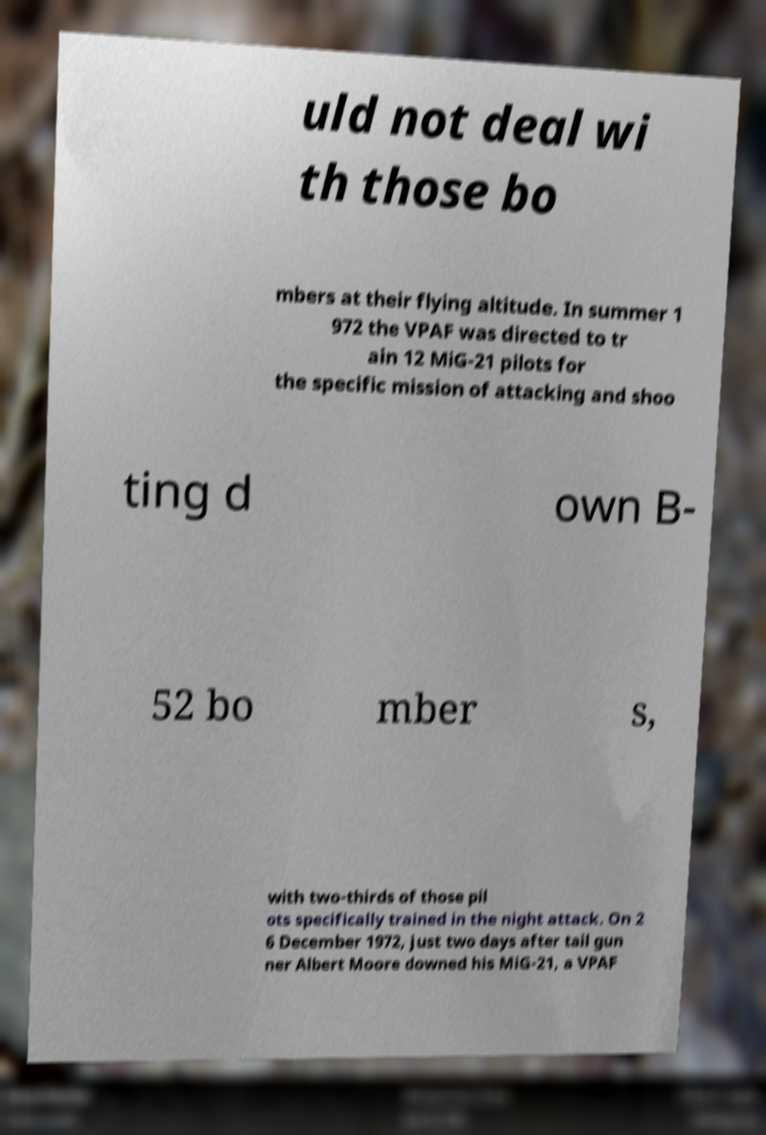Please read and relay the text visible in this image. What does it say? uld not deal wi th those bo mbers at their flying altitude. In summer 1 972 the VPAF was directed to tr ain 12 MiG-21 pilots for the specific mission of attacking and shoo ting d own B- 52 bo mber s, with two-thirds of those pil ots specifically trained in the night attack. On 2 6 December 1972, just two days after tail gun ner Albert Moore downed his MiG-21, a VPAF 